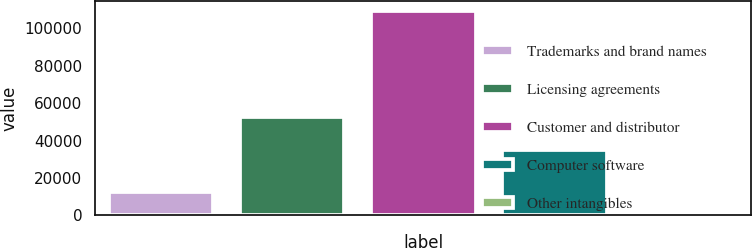<chart> <loc_0><loc_0><loc_500><loc_500><bar_chart><fcel>Trademarks and brand names<fcel>Licensing agreements<fcel>Customer and distributor<fcel>Computer software<fcel>Other intangibles<nl><fcel>12431<fcel>52707<fcel>109253<fcel>35116<fcel>1673<nl></chart> 